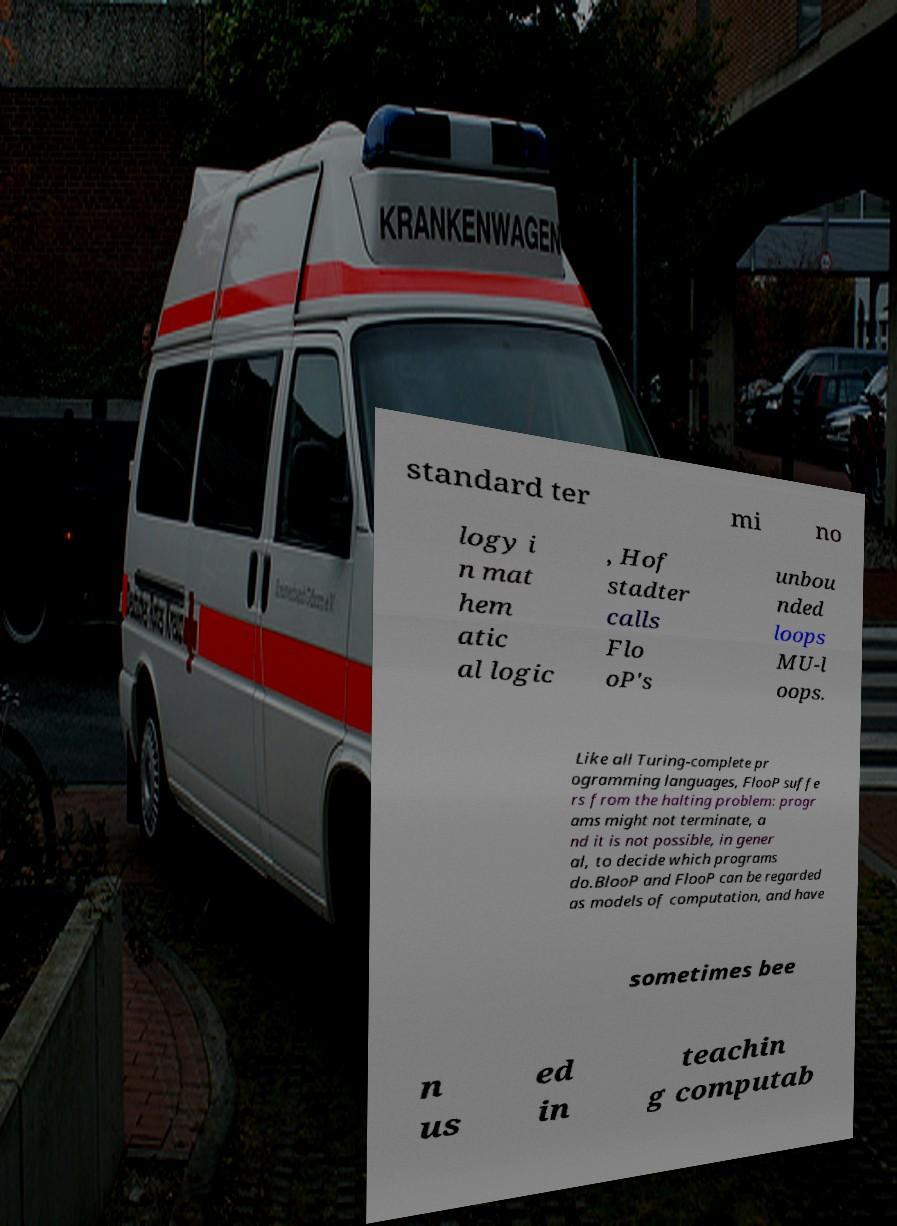Can you accurately transcribe the text from the provided image for me? standard ter mi no logy i n mat hem atic al logic , Hof stadter calls Flo oP's unbou nded loops MU-l oops. Like all Turing-complete pr ogramming languages, FlooP suffe rs from the halting problem: progr ams might not terminate, a nd it is not possible, in gener al, to decide which programs do.BlooP and FlooP can be regarded as models of computation, and have sometimes bee n us ed in teachin g computab 